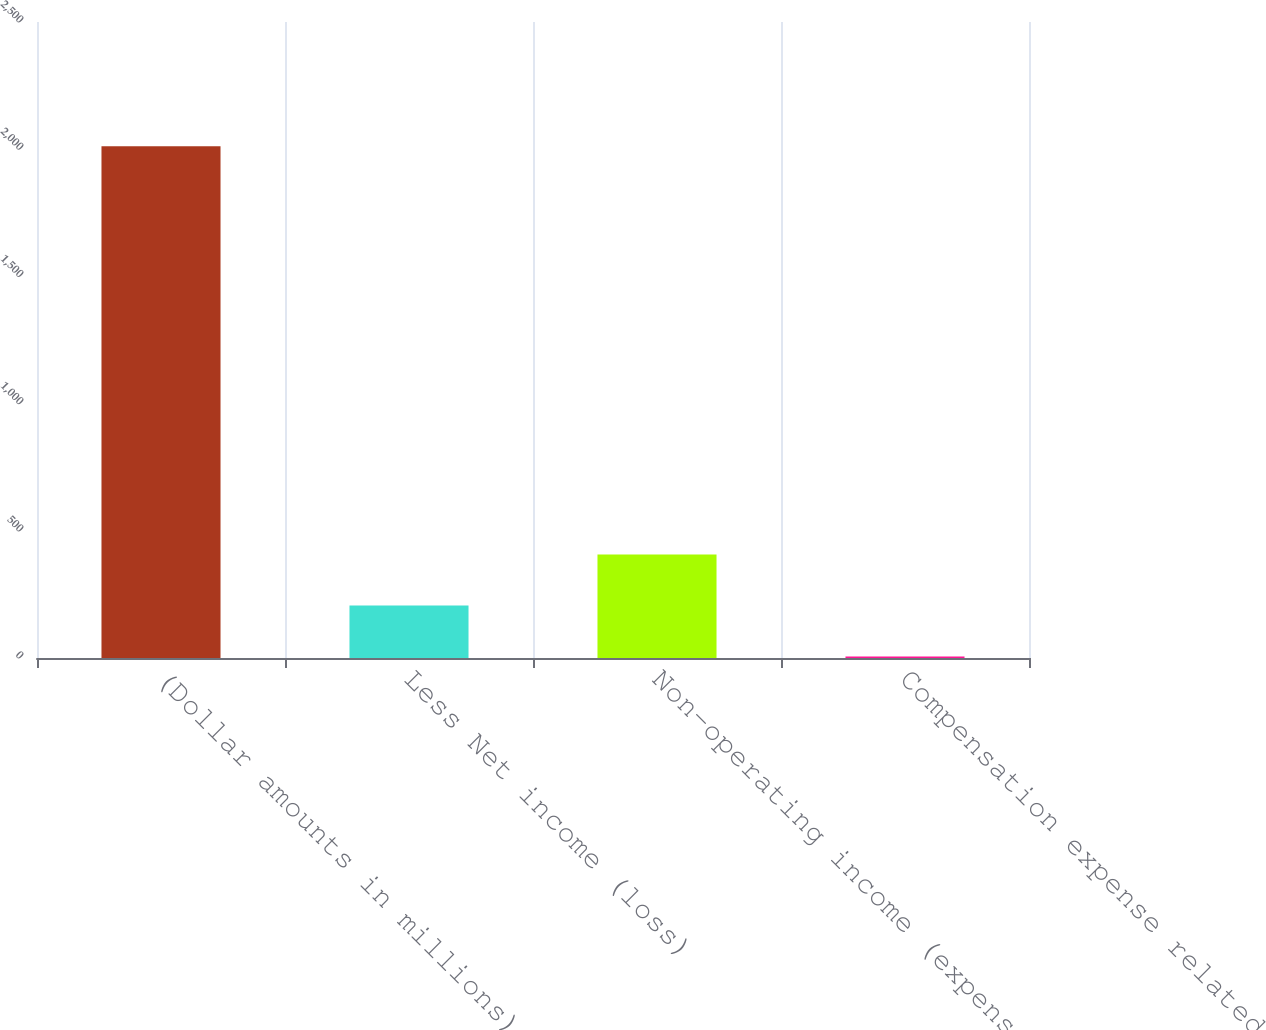Convert chart to OTSL. <chart><loc_0><loc_0><loc_500><loc_500><bar_chart><fcel>(Dollar amounts in millions)<fcel>Less Net income (loss)<fcel>Non-operating income (expense)<fcel>Compensation expense related<nl><fcel>2012<fcel>206.6<fcel>407.2<fcel>6<nl></chart> 